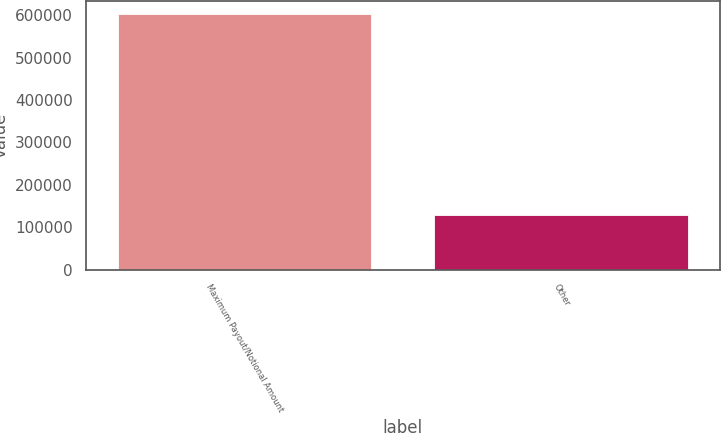Convert chart to OTSL. <chart><loc_0><loc_0><loc_500><loc_500><bar_chart><fcel>Maximum Payout/Notional Amount<fcel>Other<nl><fcel>604212<fcel>129765<nl></chart> 